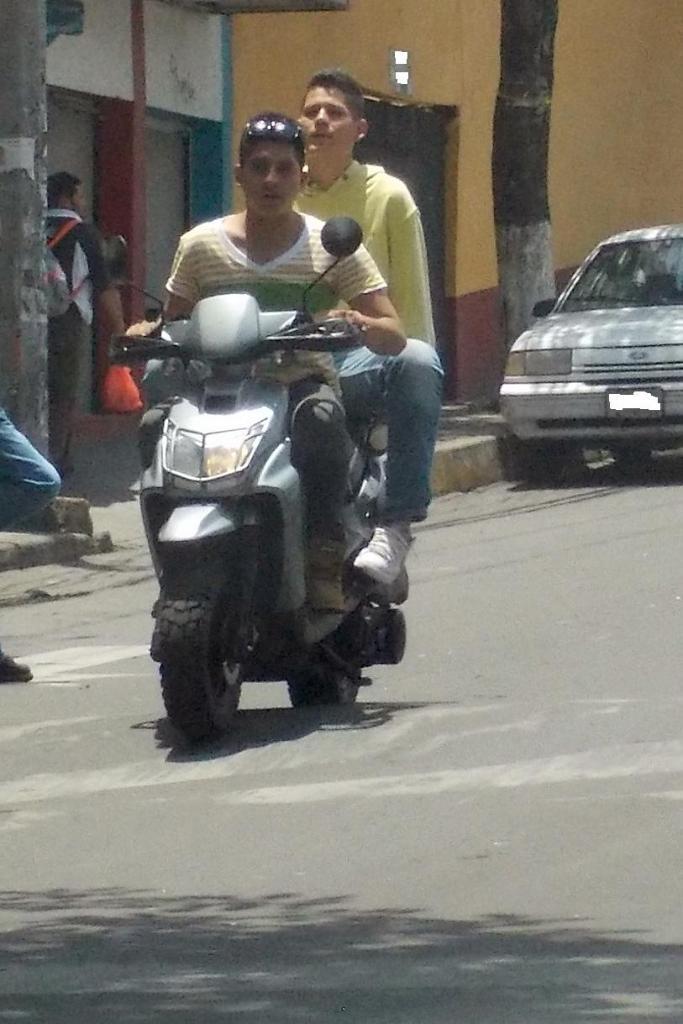Describe this image in one or two sentences. This 2 mans are sitting on a motorbike and riding. A car on road. This is tree. This is a building. This man wore bag and holding a plastic bag. 